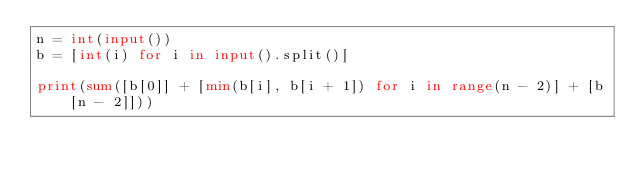Convert code to text. <code><loc_0><loc_0><loc_500><loc_500><_Python_>n = int(input())
b = [int(i) for i in input().split()]

print(sum([b[0]] + [min(b[i], b[i + 1]) for i in range(n - 2)] + [b[n - 2]]))
</code> 